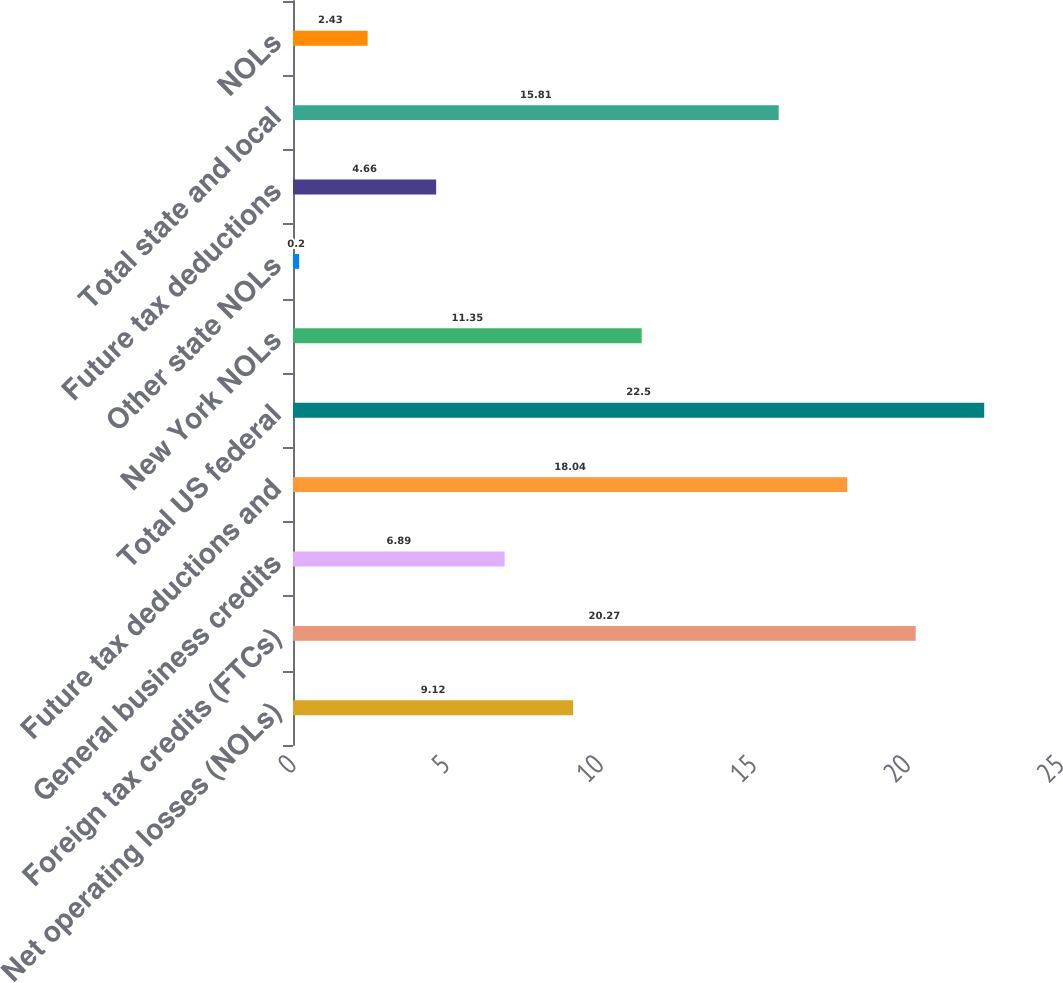<chart> <loc_0><loc_0><loc_500><loc_500><bar_chart><fcel>Net operating losses (NOLs)<fcel>Foreign tax credits (FTCs)<fcel>General business credits<fcel>Future tax deductions and<fcel>Total US federal<fcel>New York NOLs<fcel>Other state NOLs<fcel>Future tax deductions<fcel>Total state and local<fcel>NOLs<nl><fcel>9.12<fcel>20.27<fcel>6.89<fcel>18.04<fcel>22.5<fcel>11.35<fcel>0.2<fcel>4.66<fcel>15.81<fcel>2.43<nl></chart> 